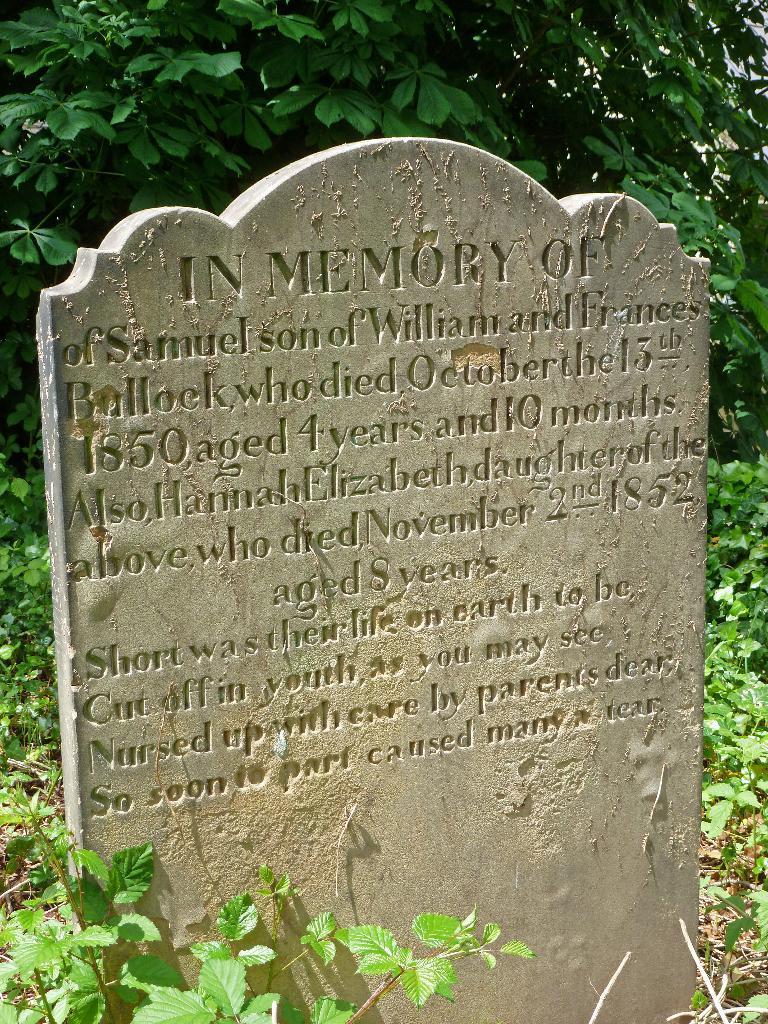Can you describe this image briefly? In this image we can see a graveyard stone and some matter is written on it and at the background of the image there are some trees. 